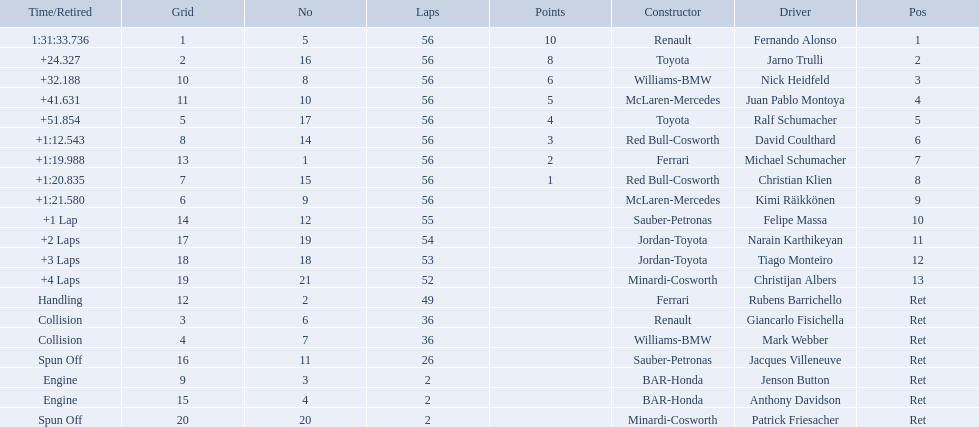Who was fernando alonso's instructor? Renault. How many laps did fernando alonso run? 56. How long did it take alonso to complete the race? 1:31:33.736. 